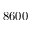Convert formula to latex. <formula><loc_0><loc_0><loc_500><loc_500>8 6 0 0</formula> 